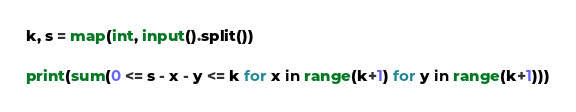<code> <loc_0><loc_0><loc_500><loc_500><_Python_>k, s = map(int, input().split())

print(sum(0 <= s - x - y <= k for x in range(k+1) for y in range(k+1)))</code> 